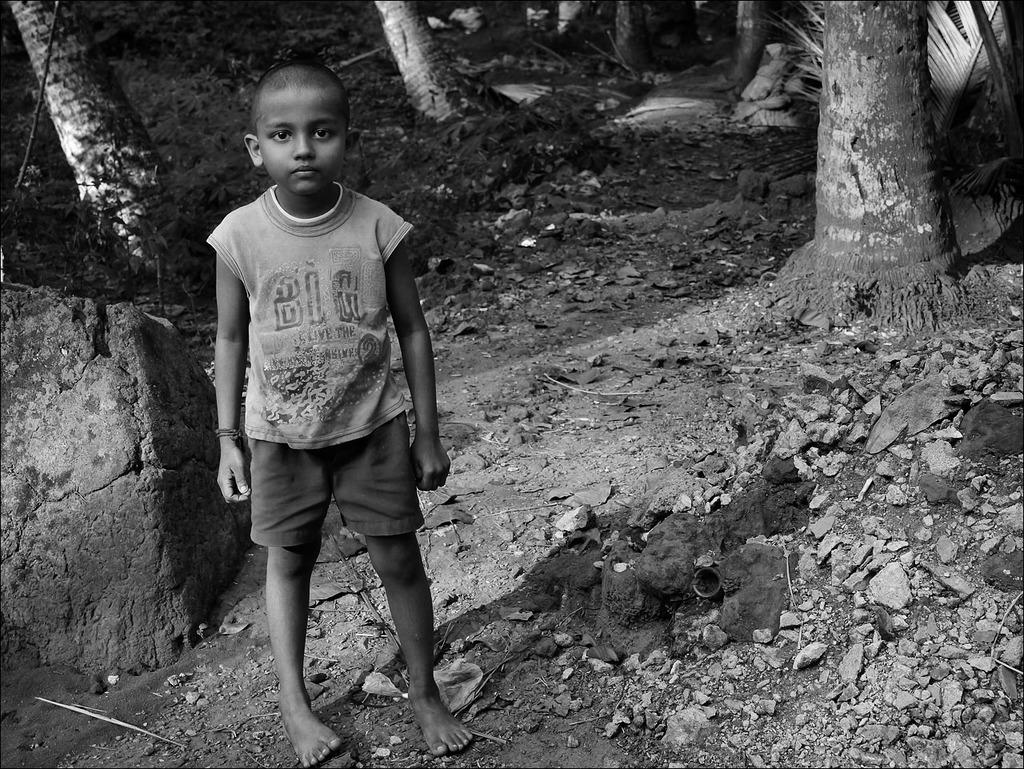What is the color scheme of the image? The image is black and white. What can be seen in the foreground of the image? There is a child standing on the ground in the image. What type of natural elements are present in the image? There are stones, plants, and a rock visible in the image. What part of the trees can be seen in the image? The bark of trees is visible in the image. What type of bulb is being used to light up the area in the image? There is no mention of any light source or bulb in the image; it is a black and white image with natural elements. Is there a volleyball game happening in the image? There is no indication of a volleyball game or any sports activity in the image. 